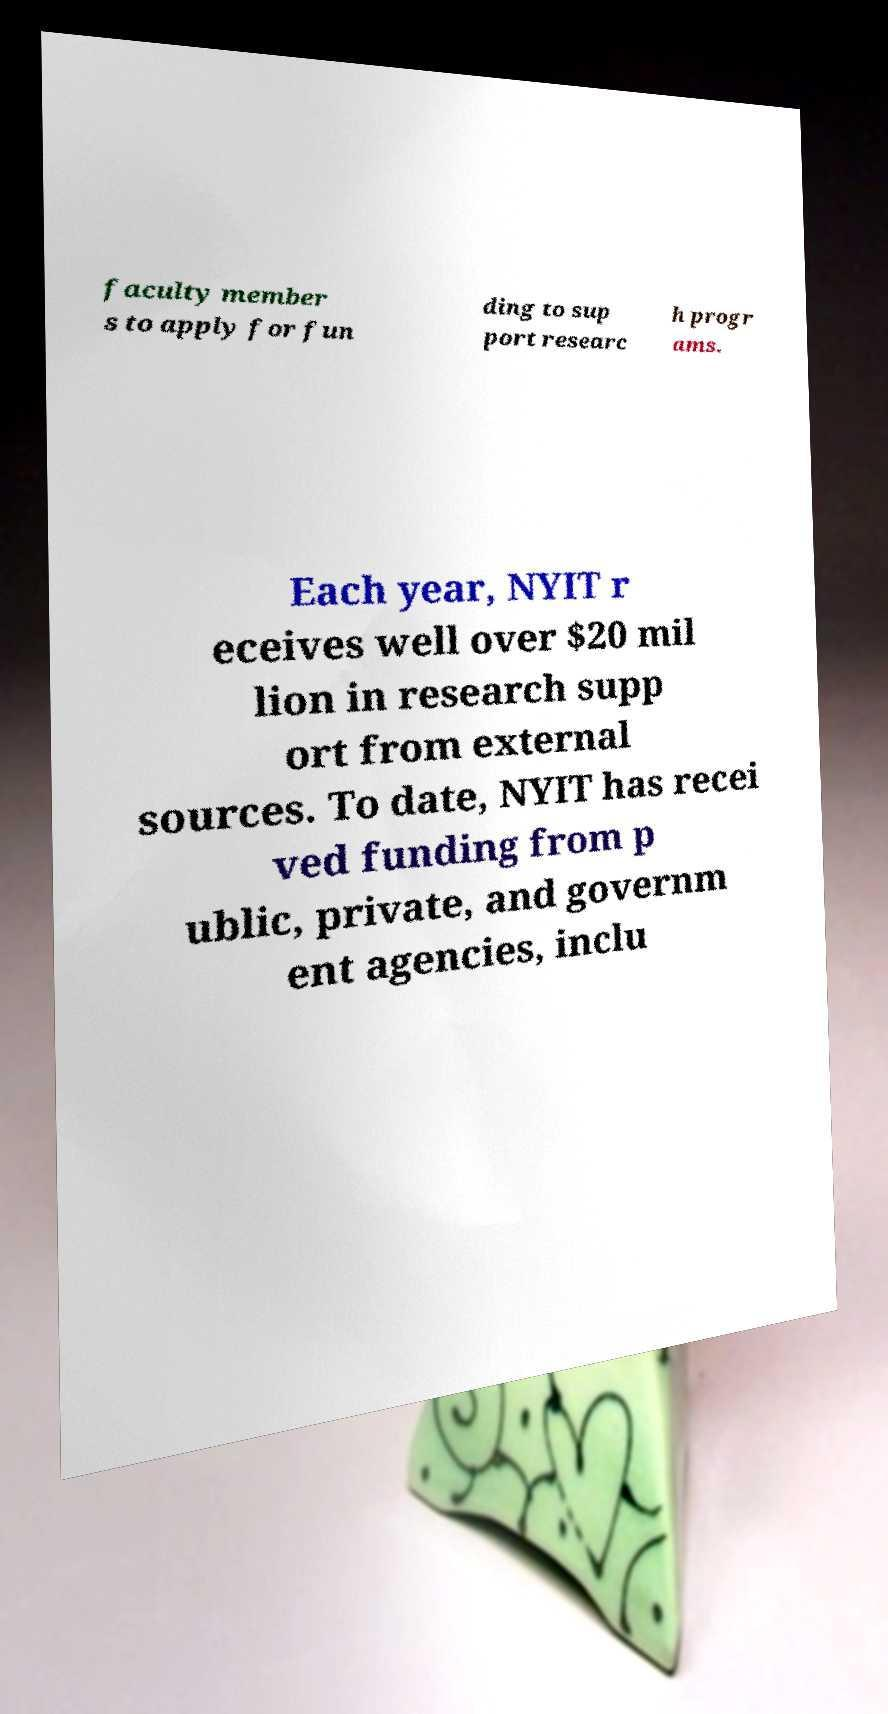There's text embedded in this image that I need extracted. Can you transcribe it verbatim? faculty member s to apply for fun ding to sup port researc h progr ams. Each year, NYIT r eceives well over $20 mil lion in research supp ort from external sources. To date, NYIT has recei ved funding from p ublic, private, and governm ent agencies, inclu 